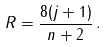<formula> <loc_0><loc_0><loc_500><loc_500>R = \frac { 8 ( j + 1 ) } { n + 2 } \, .</formula> 